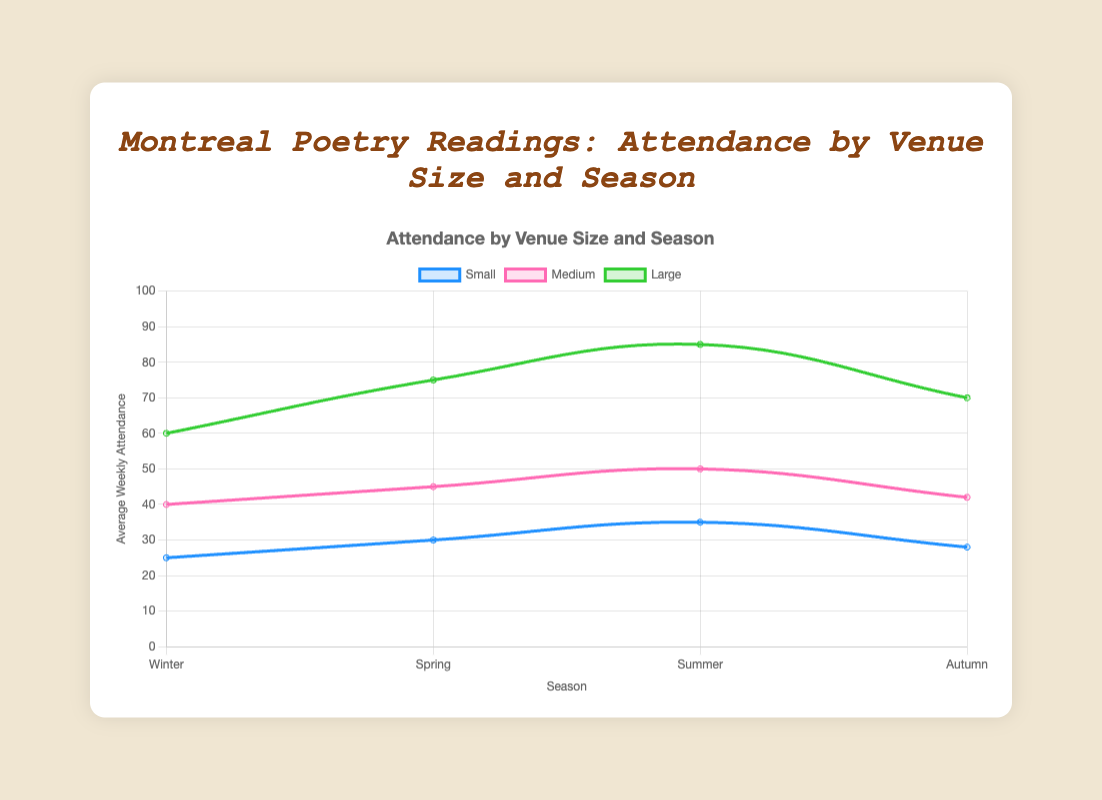Which venue size sees the highest average weekly attendance during Summer? Look at the Summer segment and compare the average weekly attendance for small, medium, and large venues. Leonard Cohen Auditorium, which is a large venue, has the highest attendance with 85 people.
Answer: Large What is the difference in average weekly attendance between Casa del Popolo in Spring and Cafe Cleopatra in Winter? Casa del Popolo (Spring) has 30 attendees, and Cafe Cleopatra (Winter) has 25 attendees. The difference is 30 - 25 = 5.
Answer: 5 Which season has the lowest average weekly attendance for small venues? Compare the values across all seasons for small venues: Winter (25), Spring (30), Summer (35), Autumn (28). Winter has the lowest attendance with 25.
Answer: Winter What is the total average weekly attendance for all venues during Autumn? Sum up the average weekly attendance of Grumpy's Bar (28), Sala Rossa (42), and Place des Arts (70). The total is 28 + 42 + 70 = 140.
Answer: 140 Is there any season where medium-sized venues have an average weekly attendance of exactly 50? Look at the data for all seasons: Winter (40), Spring (45), Summer (50), Autumn (42). Only during Summer does a medium-sized venue (Divan Orange) have an average weekly attendance of 50.
Answer: Yes Between Spring and Summer, which season sees a greater increase in average weekly attendance for large venues compared to Winter? Compare Winter (60) to Spring (75) and Summer (85). The increase from Winter to Spring is 75 - 60 = 15, and Winter to Summer is 85 - 60 = 25. Summer sees the greater increase.
Answer: Summer What is the average weekly attendance for small venues throughout the year? Sum the attendance for small venues across all seasons: Winter (25), Spring (30), Summer (35), Autumn (28). The total is 25 + 30 + 35 + 28 = 118. The average is 118 / 4 = 29.5.
Answer: 29.5 Are medium-sized venues more popular in Spring or Autumn, based on the average weekly attendance? Compare the average weekly attendance in Spring (45) and Autumn (42). Spring has a higher attendance.
Answer: Spring Which venue size has the most consistent attendance across all seasons? Calculate the range (difference between max and min) of attendance values for each venue size: Small (35-25=10), Medium (50-40=10), Large (85-60=25). Both Small and Medium have a range of 10 but Large has a larger range. Hence, Small and Medium are the most consistent.
Answer: Small and Medium What is the overall trend in attendance from Winter to Summer for large venues? Compare the data points for large venues over Winter (60), Spring (75), and Summer (85). The trend shows a steady increase in attendance from Winter to Summer.
Answer: Increasing 